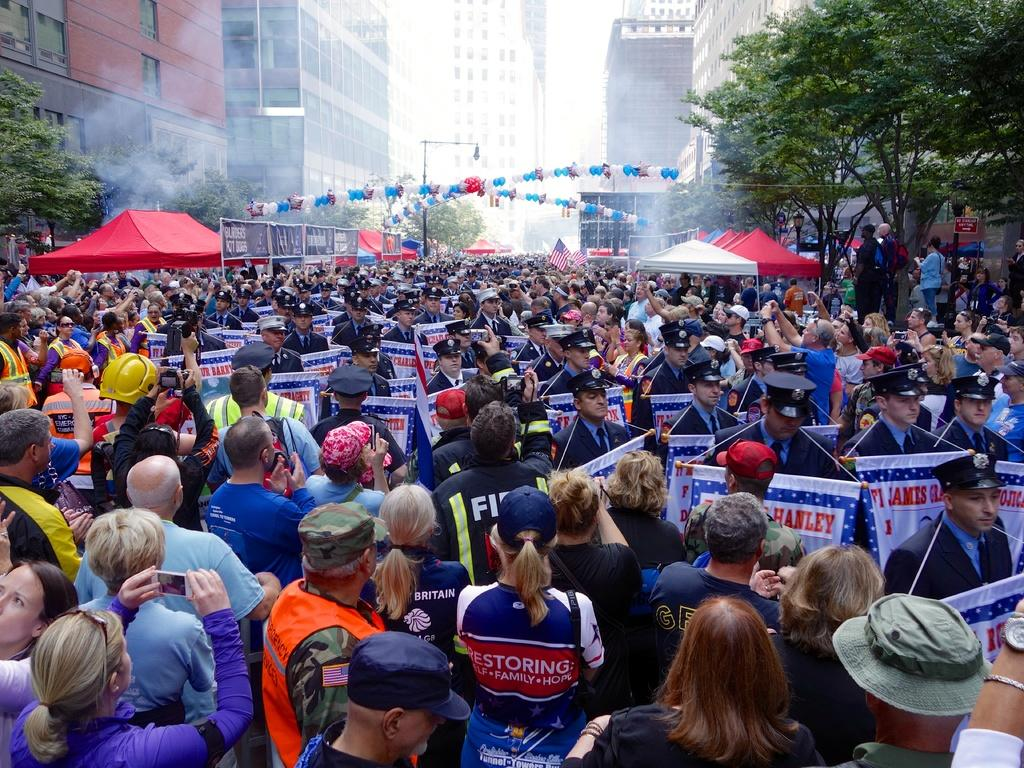How many people can be seen in the image? There are many people in the image. What decorative items are present in the image? There are banners and flags in the image. What type of temporary structures are visible in the image? There are tents in the image. What additional decorative items can be seen in the image? There are balloons in the image. What type of vertical structures are present in the image? There are light poles in the image. What type of natural elements are present in the image? There are trees in the image. What type of man-made structures are present in the image? There are buildings in the image. What is the source of the smoke visible in the image? The source of the smoke is not specified in the image. What part of the natural environment is visible in the image? The sky is visible in the image. What type of bait is being used to attract the beast in the image? There is no bait or beast present in the image. What is the color of the copper used to construct the light poles in the image? The image does not specify the color or material of the light poles. 